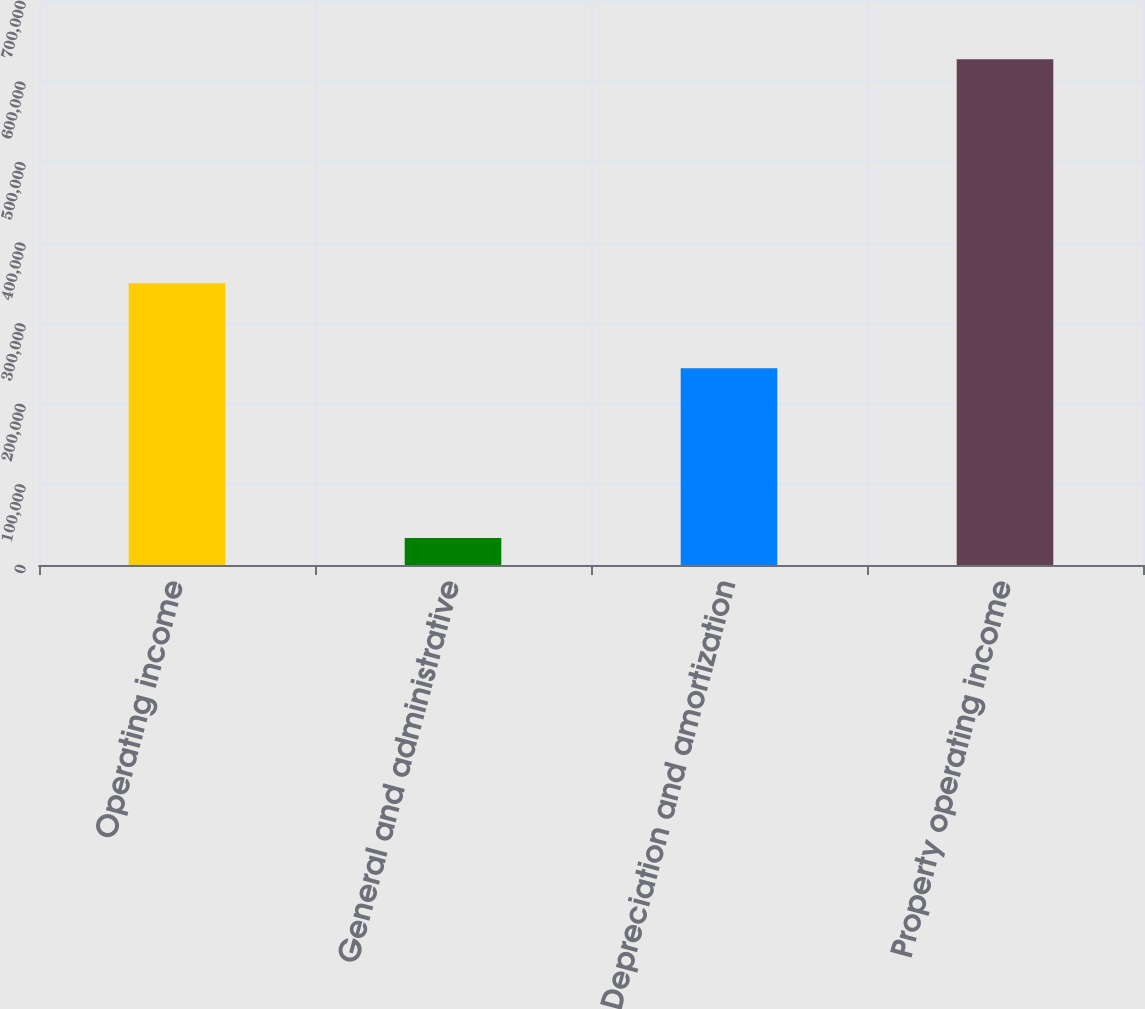Convert chart. <chart><loc_0><loc_0><loc_500><loc_500><bar_chart><fcel>Operating income<fcel>General and administrative<fcel>Depreciation and amortization<fcel>Property operating income<nl><fcel>349721<fcel>33600<fcel>244245<fcel>627566<nl></chart> 